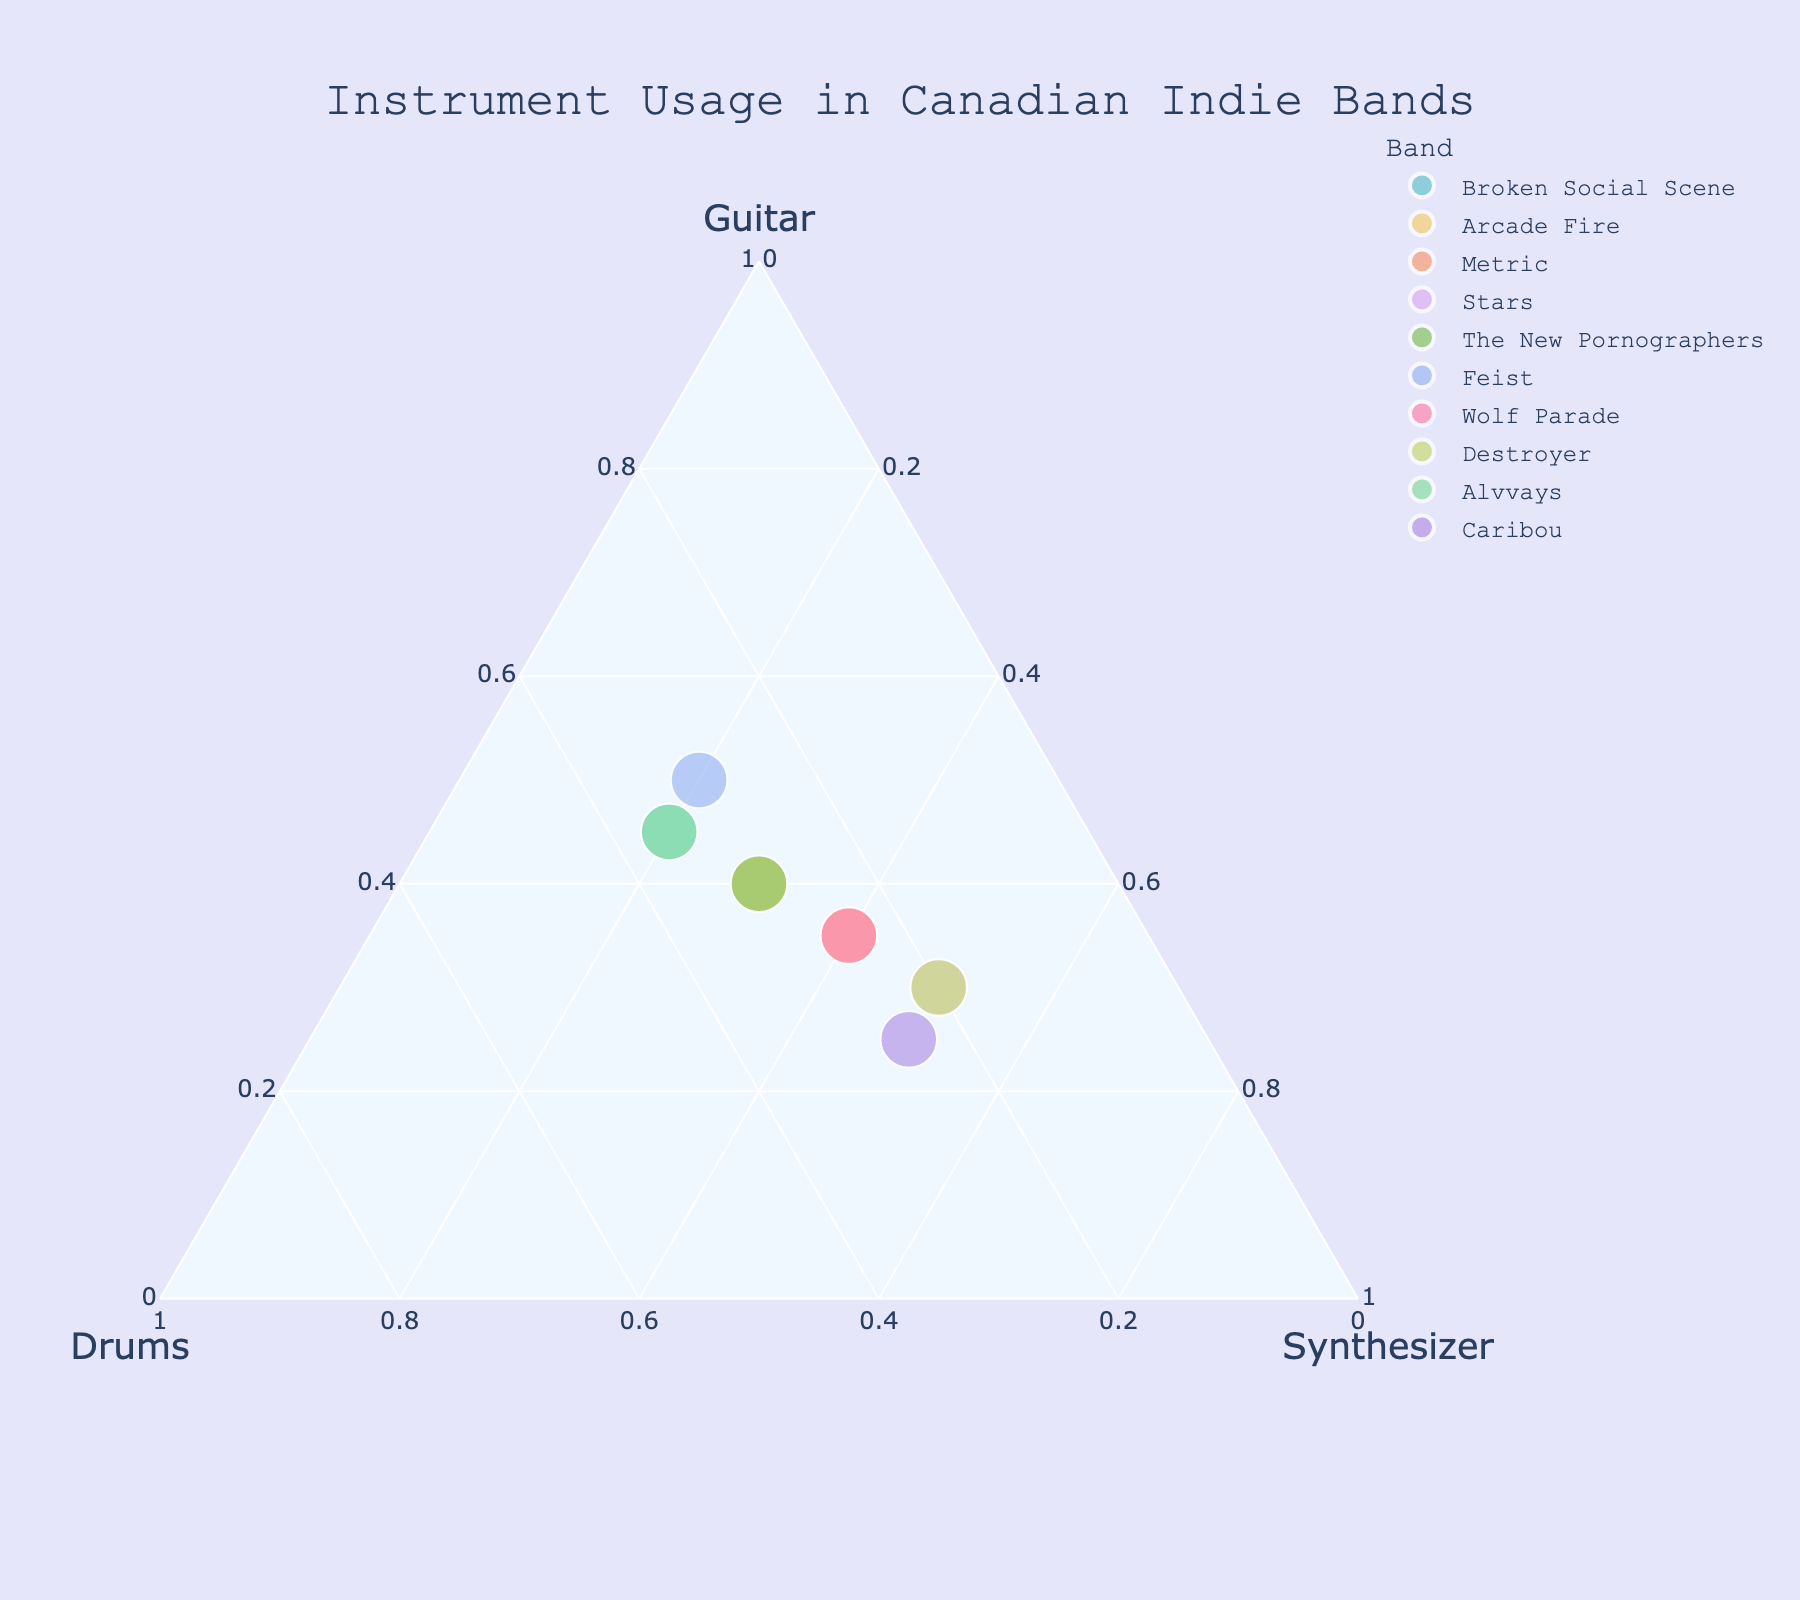What's the title of the figure? The title appears at the top of the figure, typically centered and slightly larger in font size
Answer: Instrument Usage in Canadian Indie Bands How many bands are represented in the figure? Count the number of distinct points or labels in the ternary plot
Answer: 10 Which band has the highest proportion of Synthesizer usage? Find the point closest to the vertex labeled Synthesizer
Answer: Stars and Destroyer (both 50%) Which band has equal proportions of Drums and Synthesizer? Look for the data point lying along the line where the values of Drums and Synthesizer are equal
Answer: Caribou (both 25%) Are there any bands with an equal proportion of Guitar and Synthesizer? Examine the data points positioned along the line where the Guitar and Synthesizer values are equal
Answer: No What’s the combined proportion of Drums and Synthesizer for Arcade Fire? Add the Drums and Synthesizer values for Arcade Fire
Answer: 0.60 Which band has the highest proportion of Guitar usage? Identify the data point closest to the vertex labeled Guitar
Answer: Feist (50%) How does the Guitar usage of Broken Social Scene compare to Alvvays? Compare the values of Guitar for both bands
Answer: Both have 45% Guitar usage Which band has the lowest proportion of Drums usage? Locate the point closest to the line labeled Guitar-Synthesizer axis
Answer: Stars and Destroyer (both 20%) How does the proportion of Synthesizer usage in Metric compare to Wolf Parade? Look at the Synthesizer values for both bands and compare them
Answer: Both have 40% Synthesizer usage 